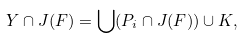Convert formula to latex. <formula><loc_0><loc_0><loc_500><loc_500>Y \cap J ( F ) = \bigcup ( P _ { i } \cap J ( F ) ) \cup K ,</formula> 